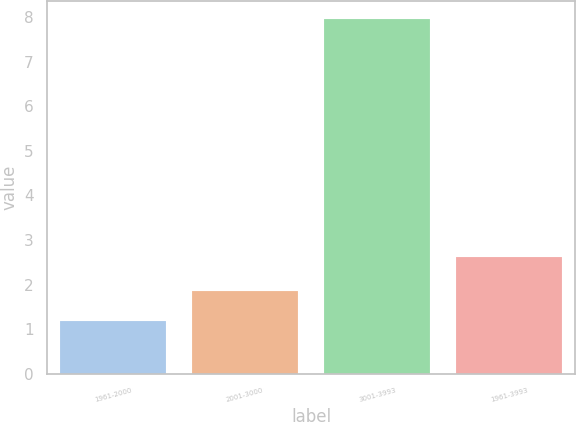Convert chart. <chart><loc_0><loc_0><loc_500><loc_500><bar_chart><fcel>1961-2000<fcel>2001-3000<fcel>3001-3993<fcel>1961-3993<nl><fcel>1.18<fcel>1.86<fcel>7.96<fcel>2.61<nl></chart> 